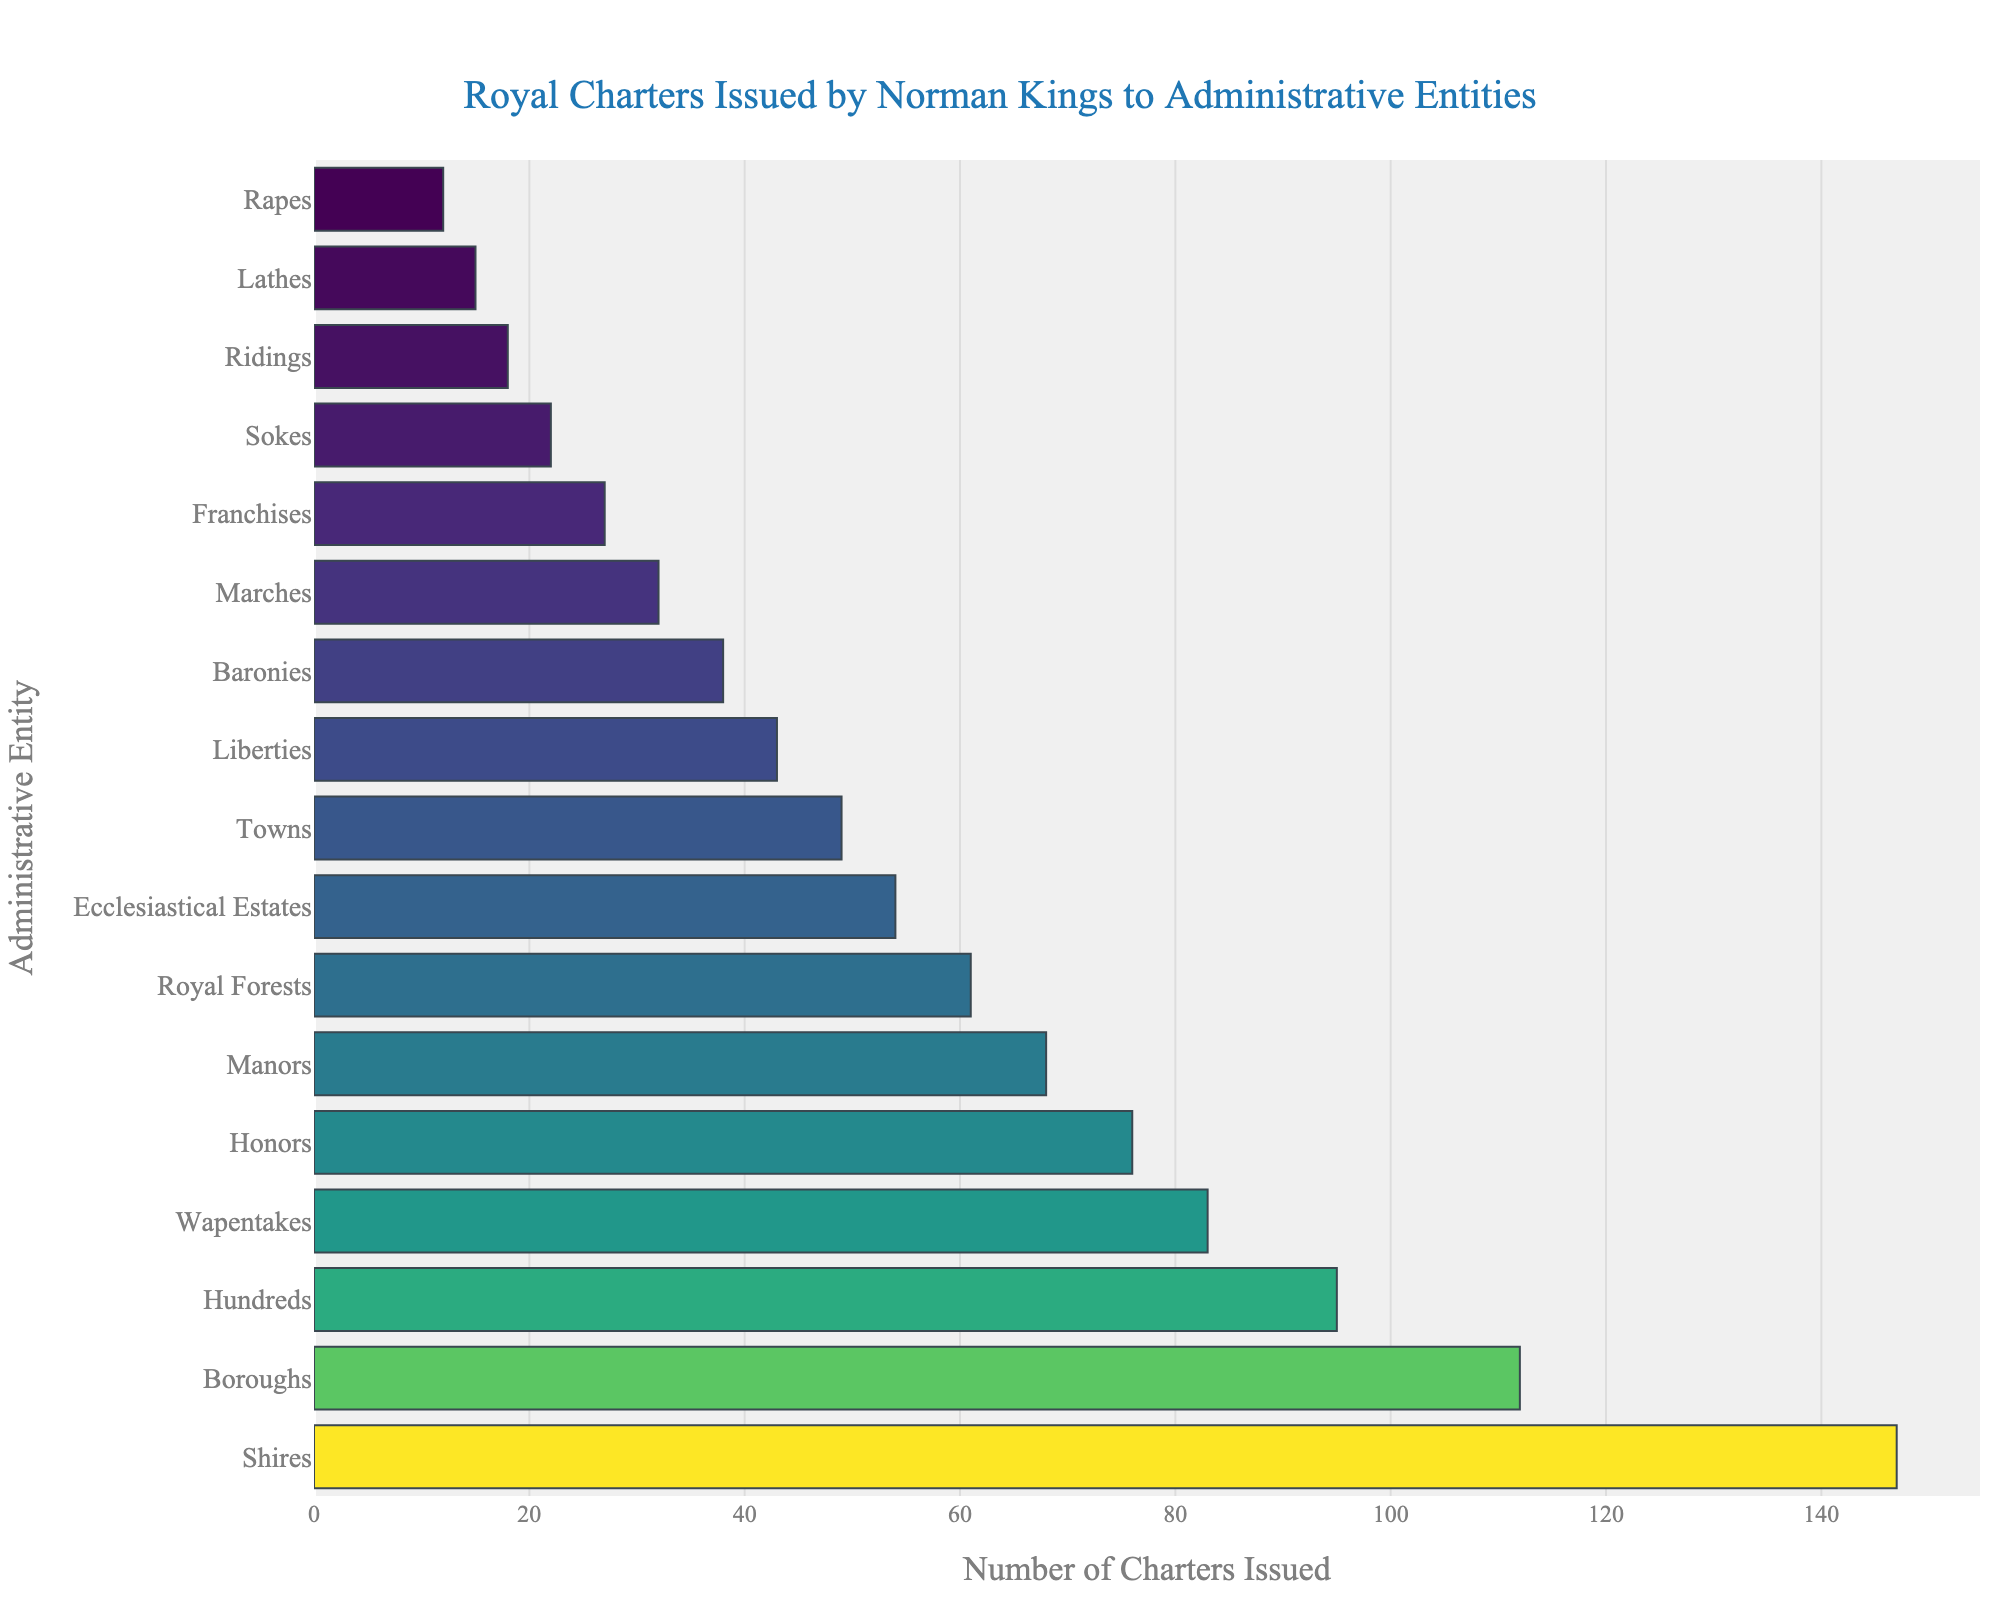Which administrative entity received the most royal charters? The highest bar in the chart corresponds to the "Shires" category, which received the most royal charters. By counting the number of charters visualized by the length of the bar, we see that "Shires" received 147 charters.
Answer: Shires Which administrative entity received the fewest royal charters? The shortest bar in the chart corresponds to the "Rapes" category, indicating that it received the fewest royal charters, with a count of 12.
Answer: Rapes How many more charters were issued to Shires compared to Boroughs? First, identify the number of charters for Shires (147) and Boroughs (112). The difference is calculated as 147 - 112 = 35.
Answer: 35 Identify the median value of charters issued to these administrative entities. To find the median, list the number of charters in numerical order: [12, 15, 18, 22, 27, 32, 38, 43, 49, 54, 61, 68, 76, 83, 95, 112, 147]. The middle value in this ordered list (for 17 entities) is the 9th one, which is 49.
Answer: 49 What fraction of the charters were issued to Royal Forests relative to the number issued to Shires? Royal Forests received 61 charters, Shires 147. The fraction is calculated as 61 / 147, which simplifies approximately to 0.415.
Answer: 0.415 How many more charters were issued to Honors and Manors combined compared to Boroughs? Total charters for Honors and Manors: 76 + 68 = 144. Charters for Boroughs: 112. The difference is 144 - 112 = 32.
Answer: 32 Which administrative entities have more than twice the number of charters as the Franchises? Franchises received 27 charters. Twice that is 54 charters. Entities receiving more than 54 charters are Shires (147), Boroughs (112), Hundreds (95), Wapentakes (83), Honors (76), Manors (68), and Royal Forests (61).
Answer: Shires, Boroughs, Hundreds, Wapentakes, Honors, Manors, Royal Forests Identify the administrative entities that have charter counts within the range of 50-100. The entities falling within 50-100 charters are Hundreds (95), Wapentakes (83), Royal Forests (61), and Ecclesiastical Estates (54).
Answer: Hundreds, Wapentakes, Royal Forests, Ecclesiastical Estates What is the difference between the highest and the lowest number of charters issued? The highest number of charters is 147 (Shires) and the lowest is 12 (Rapes). The difference is calculated as 147 - 12 = 135.
Answer: 135 